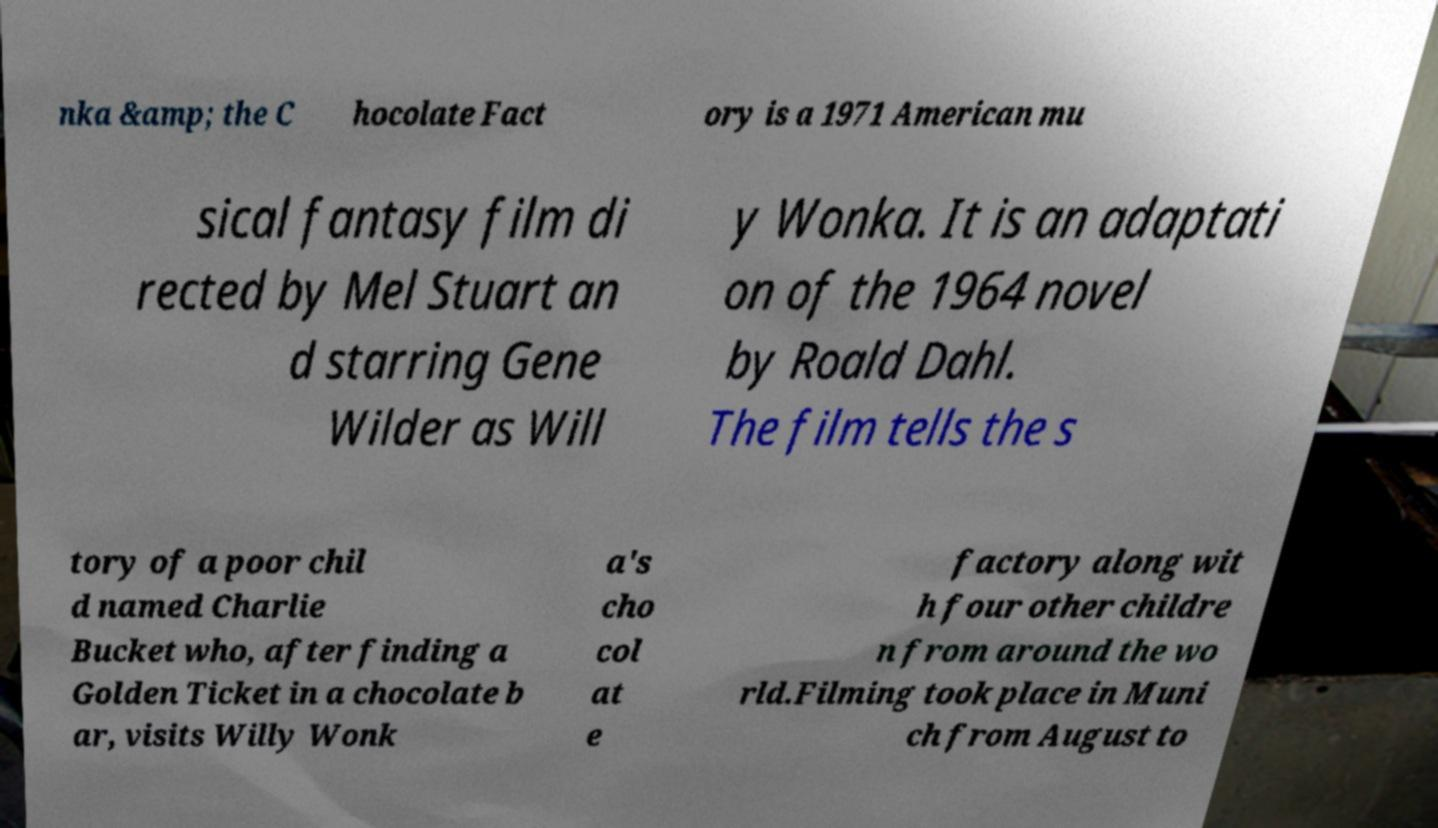There's text embedded in this image that I need extracted. Can you transcribe it verbatim? nka &amp; the C hocolate Fact ory is a 1971 American mu sical fantasy film di rected by Mel Stuart an d starring Gene Wilder as Will y Wonka. It is an adaptati on of the 1964 novel by Roald Dahl. The film tells the s tory of a poor chil d named Charlie Bucket who, after finding a Golden Ticket in a chocolate b ar, visits Willy Wonk a's cho col at e factory along wit h four other childre n from around the wo rld.Filming took place in Muni ch from August to 